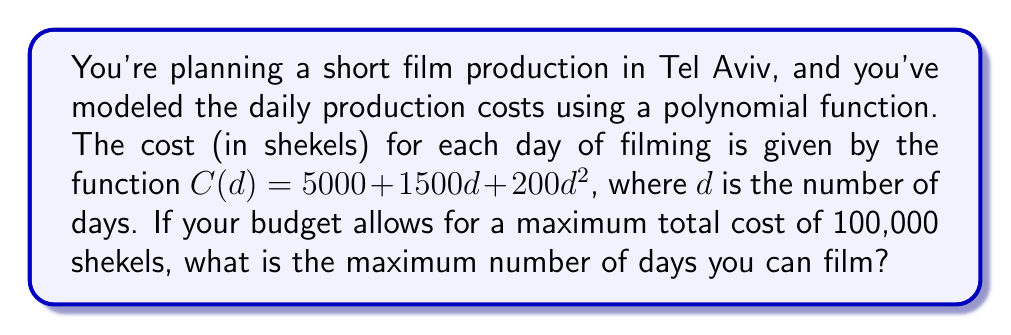Help me with this question. To solve this problem, we need to follow these steps:

1) The total cost should not exceed 100,000 shekels. So we can set up an inequality:

   $C(d) \leq 100000$

2) Substitute the given function into the inequality:

   $5000 + 1500d + 200d^2 \leq 100000$

3) Rearrange the inequality to standard form:

   $200d^2 + 1500d - 95000 \leq 0$

4) This is a quadratic inequality. To solve it, we first need to find the roots of the corresponding quadratic equation:

   $200d^2 + 1500d - 95000 = 0$

5) We can solve this using the quadratic formula: $d = \frac{-b \pm \sqrt{b^2 - 4ac}}{2a}$

   Where $a = 200$, $b = 1500$, and $c = -95000$

6) Plugging in these values:

   $d = \frac{-1500 \pm \sqrt{1500^2 - 4(200)(-95000)}}{2(200)}$

7) Simplifying:

   $d = \frac{-1500 \pm \sqrt{2250000 + 76000000}}{400} = \frac{-1500 \pm \sqrt{78250000}}{400}$

8) Calculating:

   $d \approx \frac{-1500 + 8847.61}{400}$ or $d \approx \frac{-1500 - 8847.61}{400}$

9) This gives us:

   $d \approx 18.37$ or $d \approx -25.87$

10) Since we're dealing with days, we can discard the negative solution. The inequality is less than or equal to, so we need to round down to the nearest whole number.

Therefore, the maximum number of days you can film is 18.
Answer: 18 days 